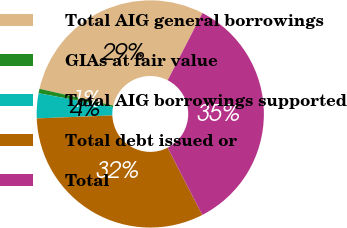<chart> <loc_0><loc_0><loc_500><loc_500><pie_chart><fcel>Total AIG general borrowings<fcel>GIAs at fair value<fcel>Total AIG borrowings supported<fcel>Total debt issued or<fcel>Total<nl><fcel>29.04%<fcel>0.64%<fcel>3.54%<fcel>31.94%<fcel>34.84%<nl></chart> 